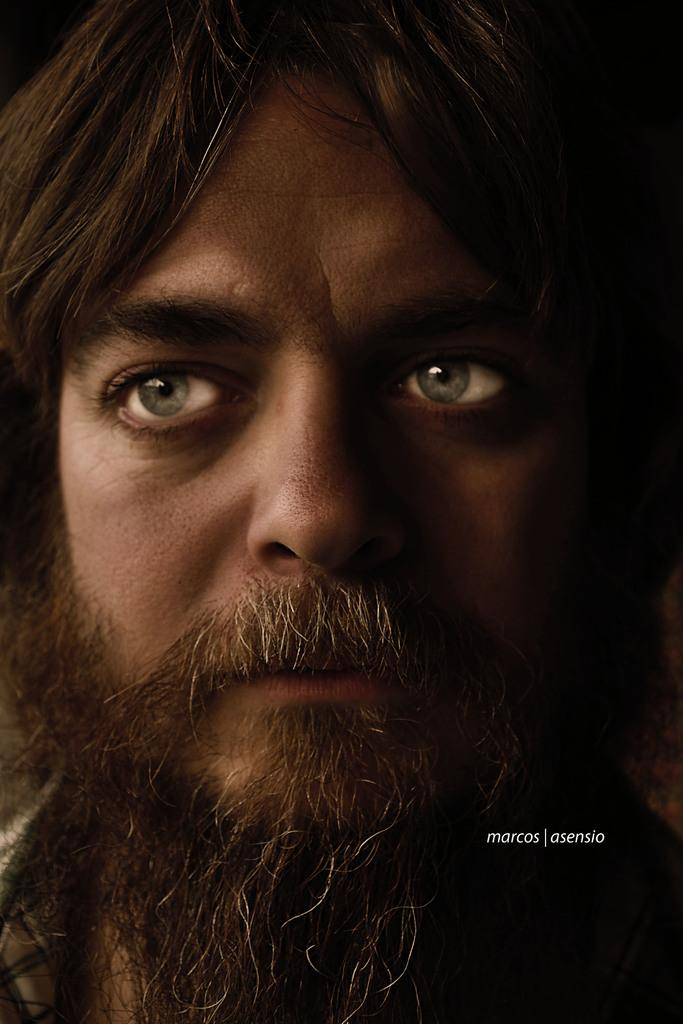What is the main subject of the image? There is a person's face in the image. In which direction is the person looking? The person is looking to the left side of the image. Can you describe any additional elements in the image? There is a watermark on the right side of the image. What type of pollution can be seen in the image? There is no pollution present in the image; it features a person's face and a watermark. Where is the achiever's hall located in the image? There is no achiever's hall present in the image. 